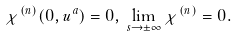<formula> <loc_0><loc_0><loc_500><loc_500>\chi ^ { ( n ) } ( 0 , u ^ { a } ) = 0 , \, \lim _ { s \rightarrow \pm \infty } \chi ^ { ( n ) } = 0 .</formula> 